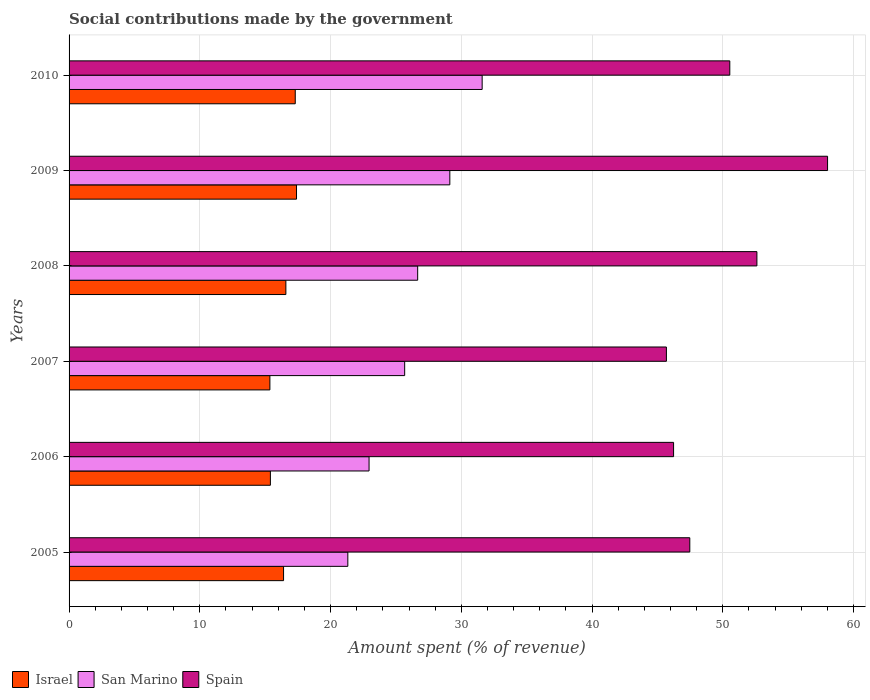How many different coloured bars are there?
Your response must be concise. 3. How many bars are there on the 1st tick from the bottom?
Keep it short and to the point. 3. What is the label of the 1st group of bars from the top?
Offer a terse response. 2010. What is the amount spent (in %) on social contributions in Israel in 2007?
Keep it short and to the point. 15.36. Across all years, what is the maximum amount spent (in %) on social contributions in San Marino?
Ensure brevity in your answer.  31.59. Across all years, what is the minimum amount spent (in %) on social contributions in Israel?
Offer a very short reply. 15.36. In which year was the amount spent (in %) on social contributions in San Marino maximum?
Keep it short and to the point. 2010. What is the total amount spent (in %) on social contributions in Israel in the graph?
Your answer should be very brief. 98.44. What is the difference between the amount spent (in %) on social contributions in San Marino in 2008 and that in 2009?
Provide a short and direct response. -2.46. What is the difference between the amount spent (in %) on social contributions in San Marino in 2009 and the amount spent (in %) on social contributions in Spain in 2007?
Give a very brief answer. -16.57. What is the average amount spent (in %) on social contributions in Spain per year?
Offer a terse response. 50.09. In the year 2010, what is the difference between the amount spent (in %) on social contributions in San Marino and amount spent (in %) on social contributions in Spain?
Your answer should be very brief. -18.94. What is the ratio of the amount spent (in %) on social contributions in Israel in 2005 to that in 2010?
Provide a succinct answer. 0.95. Is the amount spent (in %) on social contributions in Spain in 2005 less than that in 2007?
Keep it short and to the point. No. Is the difference between the amount spent (in %) on social contributions in San Marino in 2005 and 2007 greater than the difference between the amount spent (in %) on social contributions in Spain in 2005 and 2007?
Provide a succinct answer. No. What is the difference between the highest and the second highest amount spent (in %) on social contributions in Spain?
Give a very brief answer. 5.4. What is the difference between the highest and the lowest amount spent (in %) on social contributions in San Marino?
Provide a short and direct response. 10.27. In how many years, is the amount spent (in %) on social contributions in Israel greater than the average amount spent (in %) on social contributions in Israel taken over all years?
Keep it short and to the point. 3. Is the sum of the amount spent (in %) on social contributions in Spain in 2006 and 2010 greater than the maximum amount spent (in %) on social contributions in Israel across all years?
Your answer should be very brief. Yes. What does the 2nd bar from the top in 2009 represents?
Give a very brief answer. San Marino. How many bars are there?
Your answer should be compact. 18. Are all the bars in the graph horizontal?
Ensure brevity in your answer.  Yes. Are the values on the major ticks of X-axis written in scientific E-notation?
Make the answer very short. No. Does the graph contain any zero values?
Your response must be concise. No. Does the graph contain grids?
Make the answer very short. Yes. How many legend labels are there?
Your answer should be very brief. 3. What is the title of the graph?
Ensure brevity in your answer.  Social contributions made by the government. What is the label or title of the X-axis?
Offer a terse response. Amount spent (% of revenue). What is the Amount spent (% of revenue) of Israel in 2005?
Give a very brief answer. 16.41. What is the Amount spent (% of revenue) in San Marino in 2005?
Offer a terse response. 21.32. What is the Amount spent (% of revenue) in Spain in 2005?
Make the answer very short. 47.48. What is the Amount spent (% of revenue) in Israel in 2006?
Provide a short and direct response. 15.4. What is the Amount spent (% of revenue) of San Marino in 2006?
Your response must be concise. 22.94. What is the Amount spent (% of revenue) in Spain in 2006?
Give a very brief answer. 46.23. What is the Amount spent (% of revenue) of Israel in 2007?
Give a very brief answer. 15.36. What is the Amount spent (% of revenue) of San Marino in 2007?
Provide a short and direct response. 25.67. What is the Amount spent (% of revenue) in Spain in 2007?
Ensure brevity in your answer.  45.69. What is the Amount spent (% of revenue) of Israel in 2008?
Keep it short and to the point. 16.58. What is the Amount spent (% of revenue) in San Marino in 2008?
Ensure brevity in your answer.  26.66. What is the Amount spent (% of revenue) of Spain in 2008?
Make the answer very short. 52.61. What is the Amount spent (% of revenue) in Israel in 2009?
Give a very brief answer. 17.4. What is the Amount spent (% of revenue) in San Marino in 2009?
Keep it short and to the point. 29.12. What is the Amount spent (% of revenue) in Spain in 2009?
Make the answer very short. 58.01. What is the Amount spent (% of revenue) of Israel in 2010?
Keep it short and to the point. 17.3. What is the Amount spent (% of revenue) in San Marino in 2010?
Offer a terse response. 31.59. What is the Amount spent (% of revenue) of Spain in 2010?
Your answer should be very brief. 50.53. Across all years, what is the maximum Amount spent (% of revenue) in Israel?
Your answer should be very brief. 17.4. Across all years, what is the maximum Amount spent (% of revenue) of San Marino?
Provide a succinct answer. 31.59. Across all years, what is the maximum Amount spent (% of revenue) of Spain?
Provide a short and direct response. 58.01. Across all years, what is the minimum Amount spent (% of revenue) of Israel?
Provide a short and direct response. 15.36. Across all years, what is the minimum Amount spent (% of revenue) of San Marino?
Give a very brief answer. 21.32. Across all years, what is the minimum Amount spent (% of revenue) in Spain?
Your response must be concise. 45.69. What is the total Amount spent (% of revenue) in Israel in the graph?
Your response must be concise. 98.44. What is the total Amount spent (% of revenue) of San Marino in the graph?
Ensure brevity in your answer.  157.31. What is the total Amount spent (% of revenue) of Spain in the graph?
Offer a very short reply. 300.55. What is the difference between the Amount spent (% of revenue) of Israel in 2005 and that in 2006?
Provide a short and direct response. 1.01. What is the difference between the Amount spent (% of revenue) of San Marino in 2005 and that in 2006?
Offer a very short reply. -1.62. What is the difference between the Amount spent (% of revenue) in Spain in 2005 and that in 2006?
Make the answer very short. 1.24. What is the difference between the Amount spent (% of revenue) of Israel in 2005 and that in 2007?
Give a very brief answer. 1.05. What is the difference between the Amount spent (% of revenue) in San Marino in 2005 and that in 2007?
Ensure brevity in your answer.  -4.35. What is the difference between the Amount spent (% of revenue) of Spain in 2005 and that in 2007?
Provide a succinct answer. 1.79. What is the difference between the Amount spent (% of revenue) in Israel in 2005 and that in 2008?
Keep it short and to the point. -0.18. What is the difference between the Amount spent (% of revenue) in San Marino in 2005 and that in 2008?
Keep it short and to the point. -5.34. What is the difference between the Amount spent (% of revenue) of Spain in 2005 and that in 2008?
Ensure brevity in your answer.  -5.13. What is the difference between the Amount spent (% of revenue) of Israel in 2005 and that in 2009?
Your response must be concise. -0.99. What is the difference between the Amount spent (% of revenue) in San Marino in 2005 and that in 2009?
Provide a short and direct response. -7.8. What is the difference between the Amount spent (% of revenue) of Spain in 2005 and that in 2009?
Keep it short and to the point. -10.54. What is the difference between the Amount spent (% of revenue) in Israel in 2005 and that in 2010?
Your response must be concise. -0.89. What is the difference between the Amount spent (% of revenue) of San Marino in 2005 and that in 2010?
Keep it short and to the point. -10.28. What is the difference between the Amount spent (% of revenue) of Spain in 2005 and that in 2010?
Offer a very short reply. -3.06. What is the difference between the Amount spent (% of revenue) of Israel in 2006 and that in 2007?
Ensure brevity in your answer.  0.04. What is the difference between the Amount spent (% of revenue) of San Marino in 2006 and that in 2007?
Keep it short and to the point. -2.72. What is the difference between the Amount spent (% of revenue) of Spain in 2006 and that in 2007?
Keep it short and to the point. 0.55. What is the difference between the Amount spent (% of revenue) in Israel in 2006 and that in 2008?
Your answer should be compact. -1.18. What is the difference between the Amount spent (% of revenue) of San Marino in 2006 and that in 2008?
Your answer should be very brief. -3.72. What is the difference between the Amount spent (% of revenue) in Spain in 2006 and that in 2008?
Keep it short and to the point. -6.37. What is the difference between the Amount spent (% of revenue) in Israel in 2006 and that in 2009?
Your response must be concise. -2. What is the difference between the Amount spent (% of revenue) in San Marino in 2006 and that in 2009?
Your answer should be compact. -6.18. What is the difference between the Amount spent (% of revenue) of Spain in 2006 and that in 2009?
Ensure brevity in your answer.  -11.78. What is the difference between the Amount spent (% of revenue) of Israel in 2006 and that in 2010?
Ensure brevity in your answer.  -1.9. What is the difference between the Amount spent (% of revenue) of San Marino in 2006 and that in 2010?
Provide a succinct answer. -8.65. What is the difference between the Amount spent (% of revenue) of Spain in 2006 and that in 2010?
Offer a terse response. -4.3. What is the difference between the Amount spent (% of revenue) of Israel in 2007 and that in 2008?
Your answer should be very brief. -1.22. What is the difference between the Amount spent (% of revenue) in San Marino in 2007 and that in 2008?
Give a very brief answer. -0.99. What is the difference between the Amount spent (% of revenue) in Spain in 2007 and that in 2008?
Give a very brief answer. -6.92. What is the difference between the Amount spent (% of revenue) in Israel in 2007 and that in 2009?
Provide a succinct answer. -2.04. What is the difference between the Amount spent (% of revenue) of San Marino in 2007 and that in 2009?
Offer a terse response. -3.45. What is the difference between the Amount spent (% of revenue) in Spain in 2007 and that in 2009?
Keep it short and to the point. -12.33. What is the difference between the Amount spent (% of revenue) in Israel in 2007 and that in 2010?
Your response must be concise. -1.94. What is the difference between the Amount spent (% of revenue) in San Marino in 2007 and that in 2010?
Your response must be concise. -5.93. What is the difference between the Amount spent (% of revenue) of Spain in 2007 and that in 2010?
Offer a terse response. -4.85. What is the difference between the Amount spent (% of revenue) of Israel in 2008 and that in 2009?
Make the answer very short. -0.81. What is the difference between the Amount spent (% of revenue) in San Marino in 2008 and that in 2009?
Your answer should be compact. -2.46. What is the difference between the Amount spent (% of revenue) of Spain in 2008 and that in 2009?
Your response must be concise. -5.4. What is the difference between the Amount spent (% of revenue) in Israel in 2008 and that in 2010?
Your answer should be compact. -0.72. What is the difference between the Amount spent (% of revenue) in San Marino in 2008 and that in 2010?
Your answer should be compact. -4.93. What is the difference between the Amount spent (% of revenue) of Spain in 2008 and that in 2010?
Provide a succinct answer. 2.07. What is the difference between the Amount spent (% of revenue) of Israel in 2009 and that in 2010?
Your answer should be very brief. 0.1. What is the difference between the Amount spent (% of revenue) in San Marino in 2009 and that in 2010?
Your response must be concise. -2.47. What is the difference between the Amount spent (% of revenue) in Spain in 2009 and that in 2010?
Ensure brevity in your answer.  7.48. What is the difference between the Amount spent (% of revenue) in Israel in 2005 and the Amount spent (% of revenue) in San Marino in 2006?
Your answer should be very brief. -6.54. What is the difference between the Amount spent (% of revenue) of Israel in 2005 and the Amount spent (% of revenue) of Spain in 2006?
Ensure brevity in your answer.  -29.83. What is the difference between the Amount spent (% of revenue) in San Marino in 2005 and the Amount spent (% of revenue) in Spain in 2006?
Your response must be concise. -24.91. What is the difference between the Amount spent (% of revenue) of Israel in 2005 and the Amount spent (% of revenue) of San Marino in 2007?
Offer a terse response. -9.26. What is the difference between the Amount spent (% of revenue) of Israel in 2005 and the Amount spent (% of revenue) of Spain in 2007?
Your answer should be very brief. -29.28. What is the difference between the Amount spent (% of revenue) of San Marino in 2005 and the Amount spent (% of revenue) of Spain in 2007?
Provide a succinct answer. -24.37. What is the difference between the Amount spent (% of revenue) in Israel in 2005 and the Amount spent (% of revenue) in San Marino in 2008?
Offer a very short reply. -10.26. What is the difference between the Amount spent (% of revenue) of Israel in 2005 and the Amount spent (% of revenue) of Spain in 2008?
Give a very brief answer. -36.2. What is the difference between the Amount spent (% of revenue) of San Marino in 2005 and the Amount spent (% of revenue) of Spain in 2008?
Your response must be concise. -31.29. What is the difference between the Amount spent (% of revenue) in Israel in 2005 and the Amount spent (% of revenue) in San Marino in 2009?
Offer a terse response. -12.72. What is the difference between the Amount spent (% of revenue) of Israel in 2005 and the Amount spent (% of revenue) of Spain in 2009?
Your answer should be compact. -41.61. What is the difference between the Amount spent (% of revenue) of San Marino in 2005 and the Amount spent (% of revenue) of Spain in 2009?
Offer a terse response. -36.69. What is the difference between the Amount spent (% of revenue) of Israel in 2005 and the Amount spent (% of revenue) of San Marino in 2010?
Provide a short and direct response. -15.19. What is the difference between the Amount spent (% of revenue) of Israel in 2005 and the Amount spent (% of revenue) of Spain in 2010?
Give a very brief answer. -34.13. What is the difference between the Amount spent (% of revenue) of San Marino in 2005 and the Amount spent (% of revenue) of Spain in 2010?
Your answer should be compact. -29.21. What is the difference between the Amount spent (% of revenue) of Israel in 2006 and the Amount spent (% of revenue) of San Marino in 2007?
Provide a short and direct response. -10.27. What is the difference between the Amount spent (% of revenue) of Israel in 2006 and the Amount spent (% of revenue) of Spain in 2007?
Provide a succinct answer. -30.29. What is the difference between the Amount spent (% of revenue) of San Marino in 2006 and the Amount spent (% of revenue) of Spain in 2007?
Make the answer very short. -22.74. What is the difference between the Amount spent (% of revenue) in Israel in 2006 and the Amount spent (% of revenue) in San Marino in 2008?
Provide a succinct answer. -11.26. What is the difference between the Amount spent (% of revenue) of Israel in 2006 and the Amount spent (% of revenue) of Spain in 2008?
Your answer should be very brief. -37.21. What is the difference between the Amount spent (% of revenue) of San Marino in 2006 and the Amount spent (% of revenue) of Spain in 2008?
Your response must be concise. -29.66. What is the difference between the Amount spent (% of revenue) of Israel in 2006 and the Amount spent (% of revenue) of San Marino in 2009?
Your answer should be very brief. -13.72. What is the difference between the Amount spent (% of revenue) of Israel in 2006 and the Amount spent (% of revenue) of Spain in 2009?
Make the answer very short. -42.61. What is the difference between the Amount spent (% of revenue) in San Marino in 2006 and the Amount spent (% of revenue) in Spain in 2009?
Your answer should be very brief. -35.07. What is the difference between the Amount spent (% of revenue) of Israel in 2006 and the Amount spent (% of revenue) of San Marino in 2010?
Keep it short and to the point. -16.2. What is the difference between the Amount spent (% of revenue) of Israel in 2006 and the Amount spent (% of revenue) of Spain in 2010?
Your answer should be very brief. -35.14. What is the difference between the Amount spent (% of revenue) in San Marino in 2006 and the Amount spent (% of revenue) in Spain in 2010?
Offer a terse response. -27.59. What is the difference between the Amount spent (% of revenue) of Israel in 2007 and the Amount spent (% of revenue) of San Marino in 2008?
Your response must be concise. -11.3. What is the difference between the Amount spent (% of revenue) in Israel in 2007 and the Amount spent (% of revenue) in Spain in 2008?
Keep it short and to the point. -37.25. What is the difference between the Amount spent (% of revenue) of San Marino in 2007 and the Amount spent (% of revenue) of Spain in 2008?
Make the answer very short. -26.94. What is the difference between the Amount spent (% of revenue) in Israel in 2007 and the Amount spent (% of revenue) in San Marino in 2009?
Give a very brief answer. -13.76. What is the difference between the Amount spent (% of revenue) in Israel in 2007 and the Amount spent (% of revenue) in Spain in 2009?
Your answer should be compact. -42.65. What is the difference between the Amount spent (% of revenue) of San Marino in 2007 and the Amount spent (% of revenue) of Spain in 2009?
Your response must be concise. -32.34. What is the difference between the Amount spent (% of revenue) in Israel in 2007 and the Amount spent (% of revenue) in San Marino in 2010?
Your answer should be compact. -16.23. What is the difference between the Amount spent (% of revenue) of Israel in 2007 and the Amount spent (% of revenue) of Spain in 2010?
Offer a very short reply. -35.18. What is the difference between the Amount spent (% of revenue) in San Marino in 2007 and the Amount spent (% of revenue) in Spain in 2010?
Ensure brevity in your answer.  -24.87. What is the difference between the Amount spent (% of revenue) of Israel in 2008 and the Amount spent (% of revenue) of San Marino in 2009?
Provide a short and direct response. -12.54. What is the difference between the Amount spent (% of revenue) of Israel in 2008 and the Amount spent (% of revenue) of Spain in 2009?
Keep it short and to the point. -41.43. What is the difference between the Amount spent (% of revenue) of San Marino in 2008 and the Amount spent (% of revenue) of Spain in 2009?
Ensure brevity in your answer.  -31.35. What is the difference between the Amount spent (% of revenue) of Israel in 2008 and the Amount spent (% of revenue) of San Marino in 2010?
Give a very brief answer. -15.01. What is the difference between the Amount spent (% of revenue) of Israel in 2008 and the Amount spent (% of revenue) of Spain in 2010?
Provide a succinct answer. -33.95. What is the difference between the Amount spent (% of revenue) in San Marino in 2008 and the Amount spent (% of revenue) in Spain in 2010?
Ensure brevity in your answer.  -23.87. What is the difference between the Amount spent (% of revenue) in Israel in 2009 and the Amount spent (% of revenue) in San Marino in 2010?
Your response must be concise. -14.2. What is the difference between the Amount spent (% of revenue) of Israel in 2009 and the Amount spent (% of revenue) of Spain in 2010?
Your answer should be compact. -33.14. What is the difference between the Amount spent (% of revenue) in San Marino in 2009 and the Amount spent (% of revenue) in Spain in 2010?
Make the answer very short. -21.41. What is the average Amount spent (% of revenue) in Israel per year?
Provide a succinct answer. 16.41. What is the average Amount spent (% of revenue) in San Marino per year?
Ensure brevity in your answer.  26.22. What is the average Amount spent (% of revenue) of Spain per year?
Keep it short and to the point. 50.09. In the year 2005, what is the difference between the Amount spent (% of revenue) in Israel and Amount spent (% of revenue) in San Marino?
Ensure brevity in your answer.  -4.91. In the year 2005, what is the difference between the Amount spent (% of revenue) of Israel and Amount spent (% of revenue) of Spain?
Provide a short and direct response. -31.07. In the year 2005, what is the difference between the Amount spent (% of revenue) in San Marino and Amount spent (% of revenue) in Spain?
Keep it short and to the point. -26.16. In the year 2006, what is the difference between the Amount spent (% of revenue) of Israel and Amount spent (% of revenue) of San Marino?
Your answer should be compact. -7.55. In the year 2006, what is the difference between the Amount spent (% of revenue) of Israel and Amount spent (% of revenue) of Spain?
Offer a very short reply. -30.84. In the year 2006, what is the difference between the Amount spent (% of revenue) of San Marino and Amount spent (% of revenue) of Spain?
Give a very brief answer. -23.29. In the year 2007, what is the difference between the Amount spent (% of revenue) of Israel and Amount spent (% of revenue) of San Marino?
Your answer should be very brief. -10.31. In the year 2007, what is the difference between the Amount spent (% of revenue) in Israel and Amount spent (% of revenue) in Spain?
Your answer should be very brief. -30.33. In the year 2007, what is the difference between the Amount spent (% of revenue) in San Marino and Amount spent (% of revenue) in Spain?
Provide a succinct answer. -20.02. In the year 2008, what is the difference between the Amount spent (% of revenue) in Israel and Amount spent (% of revenue) in San Marino?
Make the answer very short. -10.08. In the year 2008, what is the difference between the Amount spent (% of revenue) in Israel and Amount spent (% of revenue) in Spain?
Provide a succinct answer. -36.03. In the year 2008, what is the difference between the Amount spent (% of revenue) in San Marino and Amount spent (% of revenue) in Spain?
Offer a terse response. -25.95. In the year 2009, what is the difference between the Amount spent (% of revenue) of Israel and Amount spent (% of revenue) of San Marino?
Offer a terse response. -11.73. In the year 2009, what is the difference between the Amount spent (% of revenue) in Israel and Amount spent (% of revenue) in Spain?
Make the answer very short. -40.62. In the year 2009, what is the difference between the Amount spent (% of revenue) of San Marino and Amount spent (% of revenue) of Spain?
Your answer should be very brief. -28.89. In the year 2010, what is the difference between the Amount spent (% of revenue) of Israel and Amount spent (% of revenue) of San Marino?
Give a very brief answer. -14.3. In the year 2010, what is the difference between the Amount spent (% of revenue) in Israel and Amount spent (% of revenue) in Spain?
Provide a short and direct response. -33.24. In the year 2010, what is the difference between the Amount spent (% of revenue) in San Marino and Amount spent (% of revenue) in Spain?
Your response must be concise. -18.94. What is the ratio of the Amount spent (% of revenue) of Israel in 2005 to that in 2006?
Your response must be concise. 1.07. What is the ratio of the Amount spent (% of revenue) in San Marino in 2005 to that in 2006?
Make the answer very short. 0.93. What is the ratio of the Amount spent (% of revenue) of Spain in 2005 to that in 2006?
Ensure brevity in your answer.  1.03. What is the ratio of the Amount spent (% of revenue) in Israel in 2005 to that in 2007?
Your answer should be compact. 1.07. What is the ratio of the Amount spent (% of revenue) of San Marino in 2005 to that in 2007?
Make the answer very short. 0.83. What is the ratio of the Amount spent (% of revenue) in Spain in 2005 to that in 2007?
Your response must be concise. 1.04. What is the ratio of the Amount spent (% of revenue) in Israel in 2005 to that in 2008?
Your response must be concise. 0.99. What is the ratio of the Amount spent (% of revenue) in San Marino in 2005 to that in 2008?
Provide a succinct answer. 0.8. What is the ratio of the Amount spent (% of revenue) of Spain in 2005 to that in 2008?
Provide a short and direct response. 0.9. What is the ratio of the Amount spent (% of revenue) of Israel in 2005 to that in 2009?
Your response must be concise. 0.94. What is the ratio of the Amount spent (% of revenue) of San Marino in 2005 to that in 2009?
Make the answer very short. 0.73. What is the ratio of the Amount spent (% of revenue) in Spain in 2005 to that in 2009?
Provide a short and direct response. 0.82. What is the ratio of the Amount spent (% of revenue) in Israel in 2005 to that in 2010?
Keep it short and to the point. 0.95. What is the ratio of the Amount spent (% of revenue) in San Marino in 2005 to that in 2010?
Give a very brief answer. 0.67. What is the ratio of the Amount spent (% of revenue) of Spain in 2005 to that in 2010?
Offer a terse response. 0.94. What is the ratio of the Amount spent (% of revenue) in San Marino in 2006 to that in 2007?
Offer a terse response. 0.89. What is the ratio of the Amount spent (% of revenue) of Spain in 2006 to that in 2007?
Make the answer very short. 1.01. What is the ratio of the Amount spent (% of revenue) in San Marino in 2006 to that in 2008?
Keep it short and to the point. 0.86. What is the ratio of the Amount spent (% of revenue) in Spain in 2006 to that in 2008?
Your response must be concise. 0.88. What is the ratio of the Amount spent (% of revenue) in Israel in 2006 to that in 2009?
Give a very brief answer. 0.89. What is the ratio of the Amount spent (% of revenue) of San Marino in 2006 to that in 2009?
Provide a short and direct response. 0.79. What is the ratio of the Amount spent (% of revenue) of Spain in 2006 to that in 2009?
Ensure brevity in your answer.  0.8. What is the ratio of the Amount spent (% of revenue) of Israel in 2006 to that in 2010?
Keep it short and to the point. 0.89. What is the ratio of the Amount spent (% of revenue) in San Marino in 2006 to that in 2010?
Provide a short and direct response. 0.73. What is the ratio of the Amount spent (% of revenue) in Spain in 2006 to that in 2010?
Offer a very short reply. 0.91. What is the ratio of the Amount spent (% of revenue) in Israel in 2007 to that in 2008?
Make the answer very short. 0.93. What is the ratio of the Amount spent (% of revenue) in San Marino in 2007 to that in 2008?
Provide a short and direct response. 0.96. What is the ratio of the Amount spent (% of revenue) in Spain in 2007 to that in 2008?
Your response must be concise. 0.87. What is the ratio of the Amount spent (% of revenue) in Israel in 2007 to that in 2009?
Provide a short and direct response. 0.88. What is the ratio of the Amount spent (% of revenue) of San Marino in 2007 to that in 2009?
Ensure brevity in your answer.  0.88. What is the ratio of the Amount spent (% of revenue) in Spain in 2007 to that in 2009?
Your answer should be compact. 0.79. What is the ratio of the Amount spent (% of revenue) of Israel in 2007 to that in 2010?
Your answer should be very brief. 0.89. What is the ratio of the Amount spent (% of revenue) in San Marino in 2007 to that in 2010?
Your answer should be very brief. 0.81. What is the ratio of the Amount spent (% of revenue) in Spain in 2007 to that in 2010?
Your answer should be compact. 0.9. What is the ratio of the Amount spent (% of revenue) in Israel in 2008 to that in 2009?
Your answer should be compact. 0.95. What is the ratio of the Amount spent (% of revenue) of San Marino in 2008 to that in 2009?
Ensure brevity in your answer.  0.92. What is the ratio of the Amount spent (% of revenue) of Spain in 2008 to that in 2009?
Keep it short and to the point. 0.91. What is the ratio of the Amount spent (% of revenue) in Israel in 2008 to that in 2010?
Your response must be concise. 0.96. What is the ratio of the Amount spent (% of revenue) of San Marino in 2008 to that in 2010?
Provide a short and direct response. 0.84. What is the ratio of the Amount spent (% of revenue) of Spain in 2008 to that in 2010?
Give a very brief answer. 1.04. What is the ratio of the Amount spent (% of revenue) in San Marino in 2009 to that in 2010?
Your answer should be compact. 0.92. What is the ratio of the Amount spent (% of revenue) of Spain in 2009 to that in 2010?
Provide a succinct answer. 1.15. What is the difference between the highest and the second highest Amount spent (% of revenue) in Israel?
Ensure brevity in your answer.  0.1. What is the difference between the highest and the second highest Amount spent (% of revenue) of San Marino?
Offer a terse response. 2.47. What is the difference between the highest and the second highest Amount spent (% of revenue) of Spain?
Keep it short and to the point. 5.4. What is the difference between the highest and the lowest Amount spent (% of revenue) in Israel?
Keep it short and to the point. 2.04. What is the difference between the highest and the lowest Amount spent (% of revenue) in San Marino?
Make the answer very short. 10.28. What is the difference between the highest and the lowest Amount spent (% of revenue) of Spain?
Offer a very short reply. 12.33. 